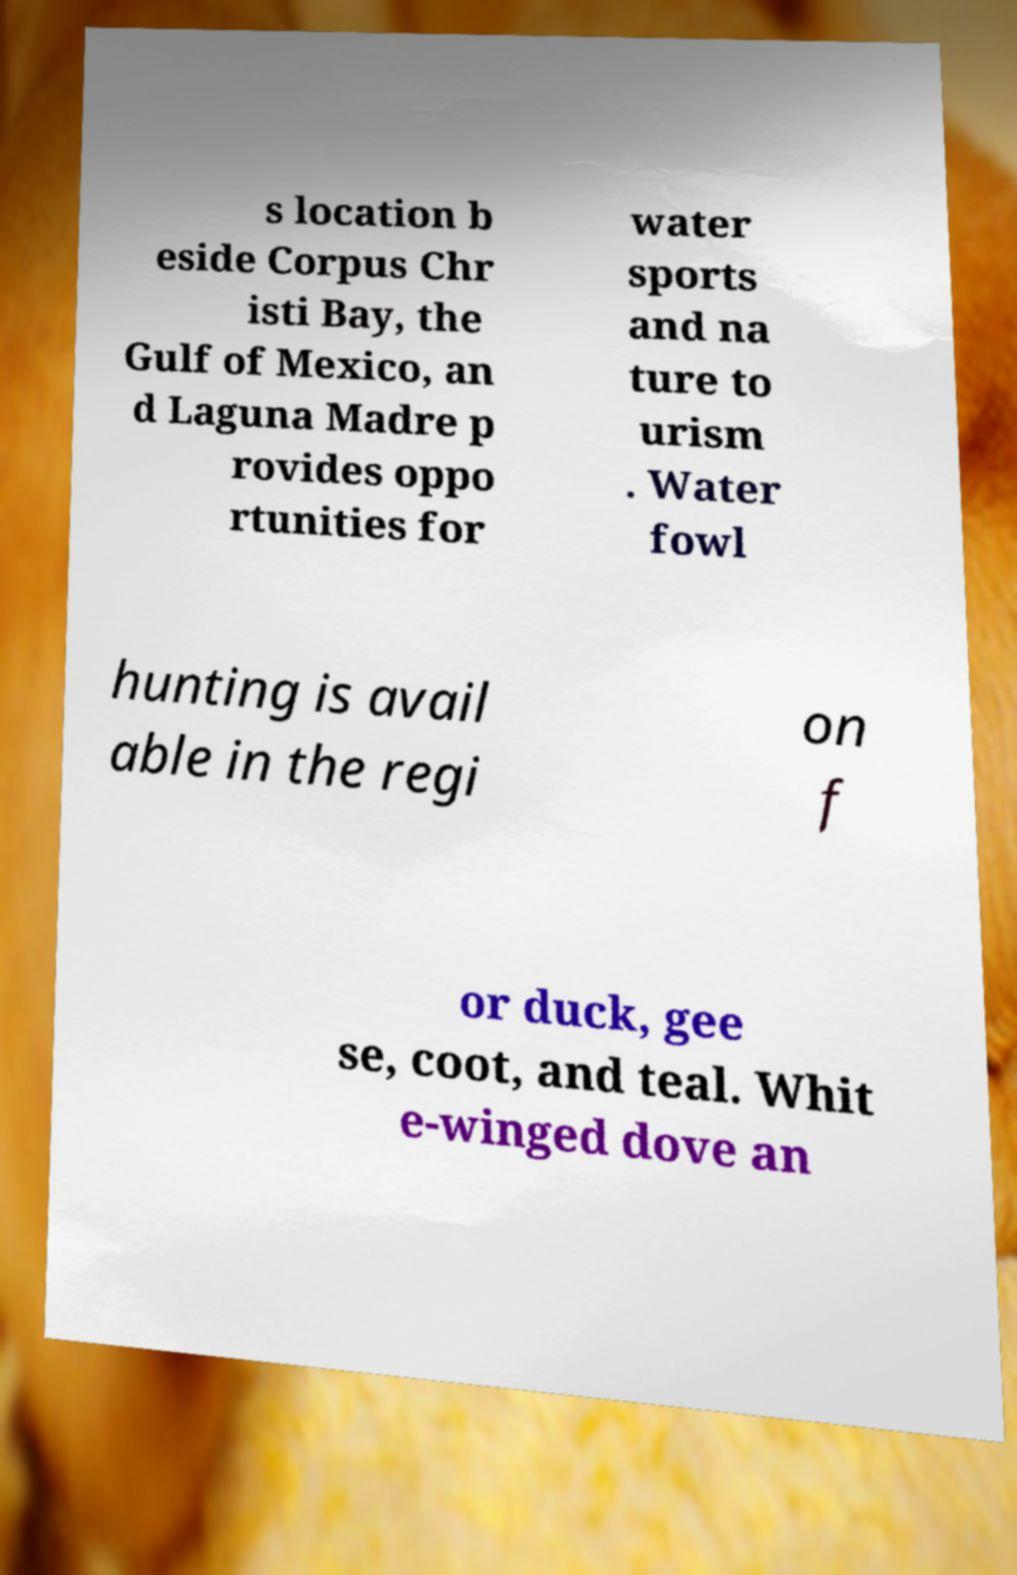I need the written content from this picture converted into text. Can you do that? s location b eside Corpus Chr isti Bay, the Gulf of Mexico, an d Laguna Madre p rovides oppo rtunities for water sports and na ture to urism . Water fowl hunting is avail able in the regi on f or duck, gee se, coot, and teal. Whit e-winged dove an 